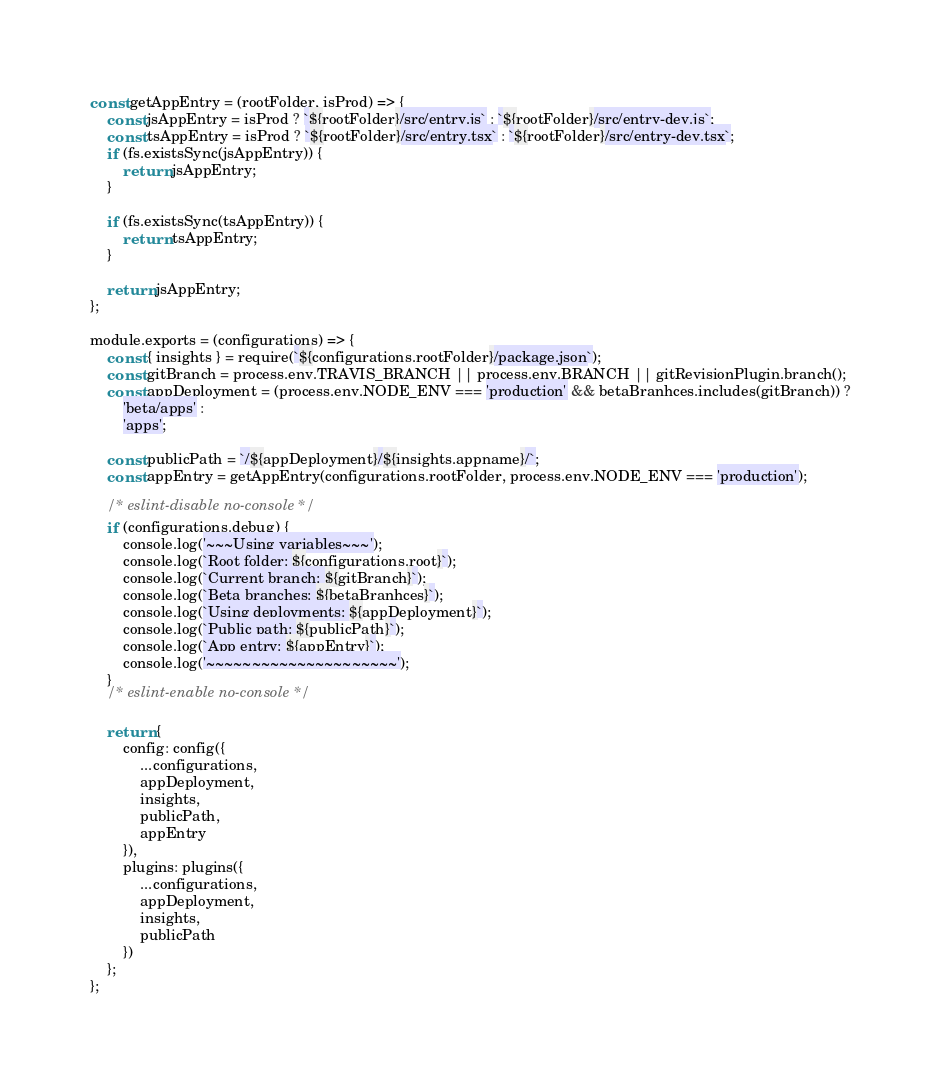<code> <loc_0><loc_0><loc_500><loc_500><_JavaScript_>
const getAppEntry = (rootFolder, isProd) => {
    const jsAppEntry = isProd ? `${rootFolder}/src/entry.js` : `${rootFolder}/src/entry-dev.js`;
    const tsAppEntry = isProd ? `${rootFolder}/src/entry.tsx` : `${rootFolder}/src/entry-dev.tsx`;
    if (fs.existsSync(jsAppEntry)) {
        return jsAppEntry;
    }

    if (fs.existsSync(tsAppEntry)) {
        return tsAppEntry;
    }

    return jsAppEntry;
};

module.exports = (configurations) => {
    const { insights } = require(`${configurations.rootFolder}/package.json`);
    const gitBranch = process.env.TRAVIS_BRANCH || process.env.BRANCH || gitRevisionPlugin.branch();
    const appDeployment = (process.env.NODE_ENV === 'production' && betaBranhces.includes(gitBranch)) ?
        'beta/apps' :
        'apps';

    const publicPath = `/${appDeployment}/${insights.appname}/`;
    const appEntry = getAppEntry(configurations.rootFolder, process.env.NODE_ENV === 'production');

    /* eslint-disable no-console */
    if (configurations.debug) {
        console.log('~~~Using variables~~~');
        console.log(`Root folder: ${configurations.root}`);
        console.log(`Current branch: ${gitBranch}`);
        console.log(`Beta branches: ${betaBranhces}`);
        console.log(`Using deployments: ${appDeployment}`);
        console.log(`Public path: ${publicPath}`);
        console.log(`App entry: ${appEntry}`);
        console.log('~~~~~~~~~~~~~~~~~~~~~');
    }
    /* eslint-enable no-console */

    return {
        config: config({
            ...configurations,
            appDeployment,
            insights,
            publicPath,
            appEntry
        }),
        plugins: plugins({
            ...configurations,
            appDeployment,
            insights,
            publicPath
        })
    };
};
</code> 